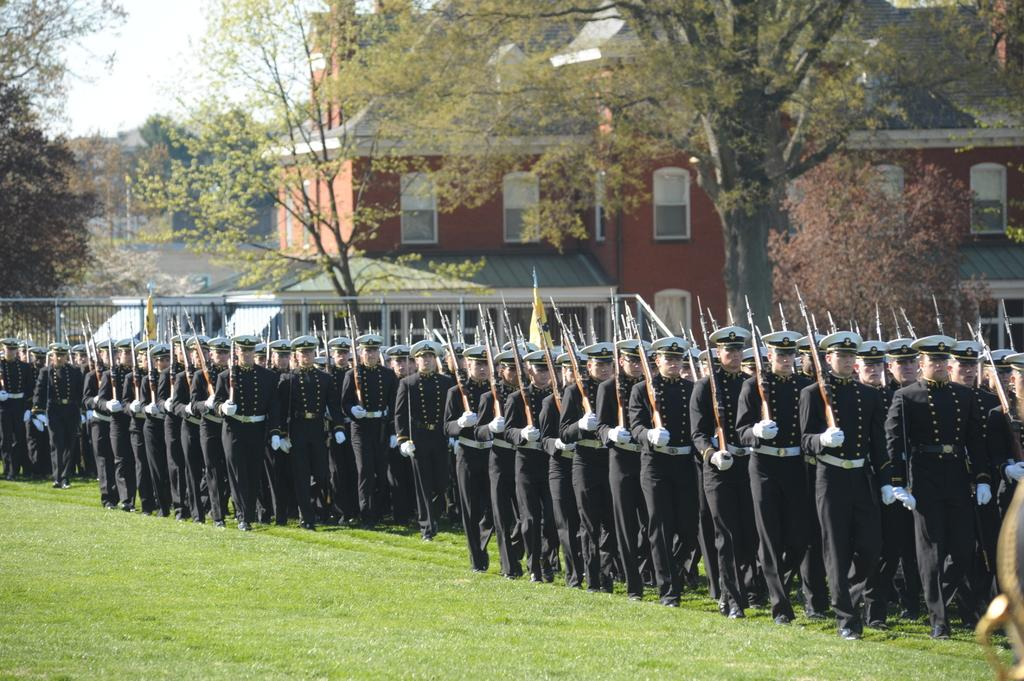How many people are in the image? There is a group of people in the image. What are some of the people wearing? Some of the people are wearing caps. What are some of the people holding? Some people are holding guns. What is the group of people doing in the image? The group of people is walking on the grass. What can be seen in the background of the image? There are buildings and trees in the background of the image. What type of shoes are the people wearing in the image? The provided facts do not mention shoes, so we cannot determine what type of shoes the people are wearing in the image. 